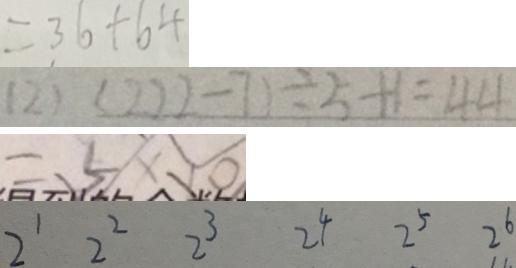Convert formula to latex. <formula><loc_0><loc_0><loc_500><loc_500>= 3 6 + 6 4 
 ( 2 ) ( 2 2 2 - 7 ) \div 5 + 1 = 4 4 
 = 5 \times 1 0 
 2 ^ { 1 } 2 ^ { 2 } 2 ^ { 3 } 2 ^ { 4 } 2 ^ { 5 } 2 ^ { 6 }</formula> 